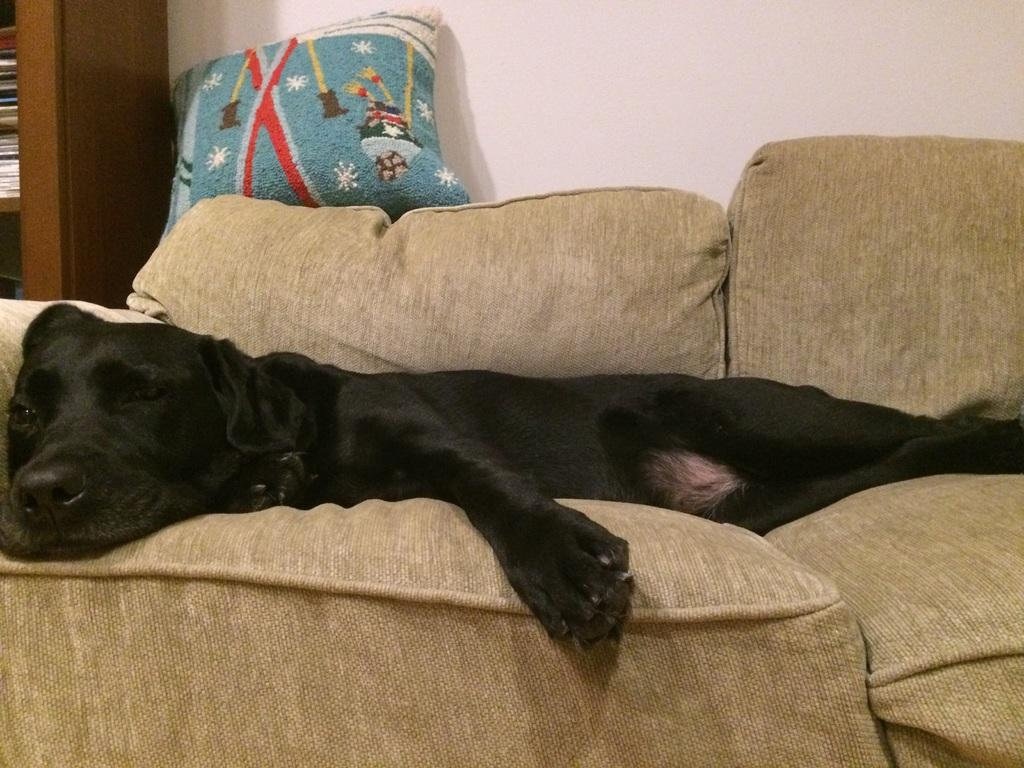What animal can be seen in the image? There is a dog in the image. What is the dog doing in the image? The dog is sleeping on a sofa. What color is the dog in the image? The dog is black in color. What type of jam is the dog eating during its nap on the sofa? There is no jam present in the image, and the dog is sleeping, not eating. 